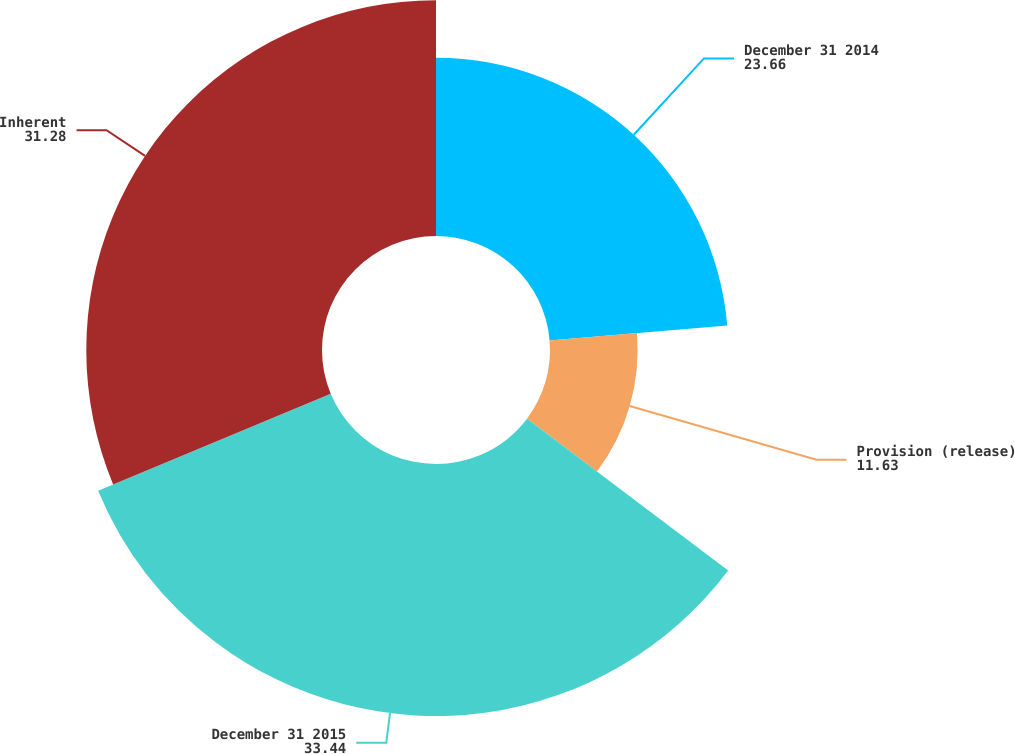Convert chart to OTSL. <chart><loc_0><loc_0><loc_500><loc_500><pie_chart><fcel>December 31 2014<fcel>Provision (release)<fcel>December 31 2015<fcel>Inherent<nl><fcel>23.66%<fcel>11.63%<fcel>33.44%<fcel>31.28%<nl></chart> 